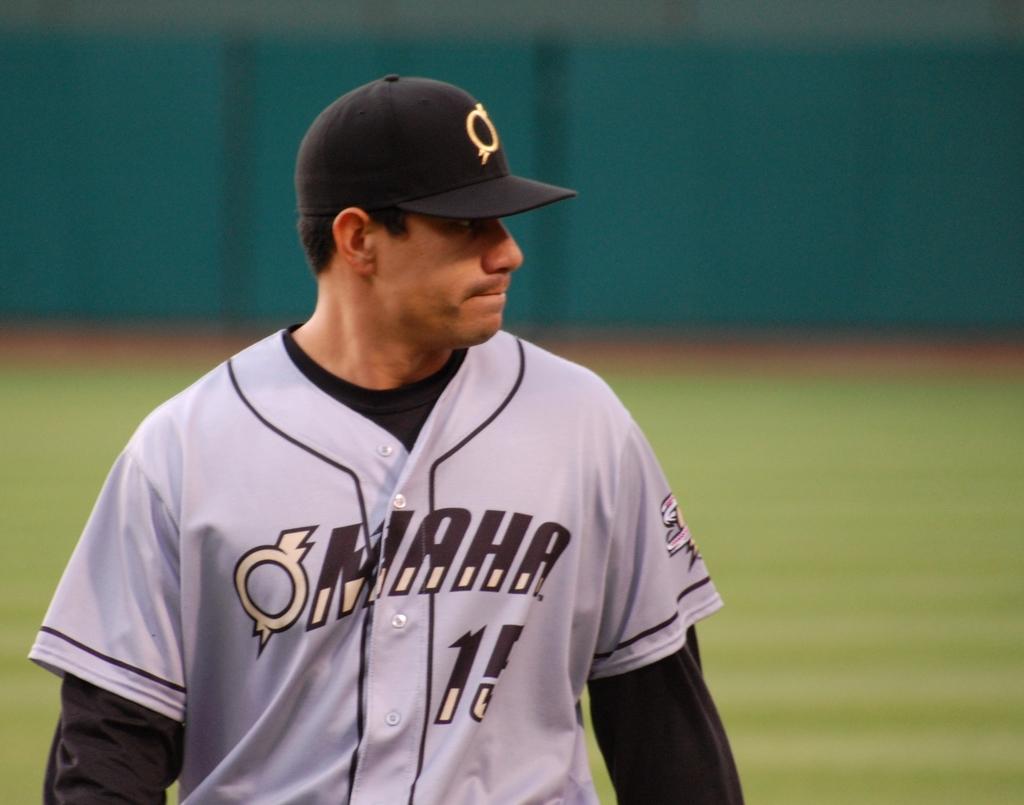What team does he play for?
Your answer should be very brief. Maha. What number is he?
Ensure brevity in your answer.  15. 